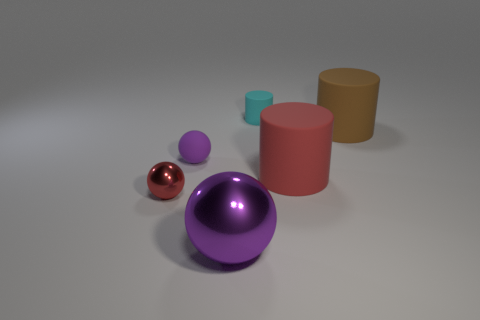Add 1 large gray metal things. How many objects exist? 7 Subtract 0 cyan balls. How many objects are left? 6 Subtract all brown spheres. Subtract all small rubber cylinders. How many objects are left? 5 Add 6 big cylinders. How many big cylinders are left? 8 Add 6 purple spheres. How many purple spheres exist? 8 